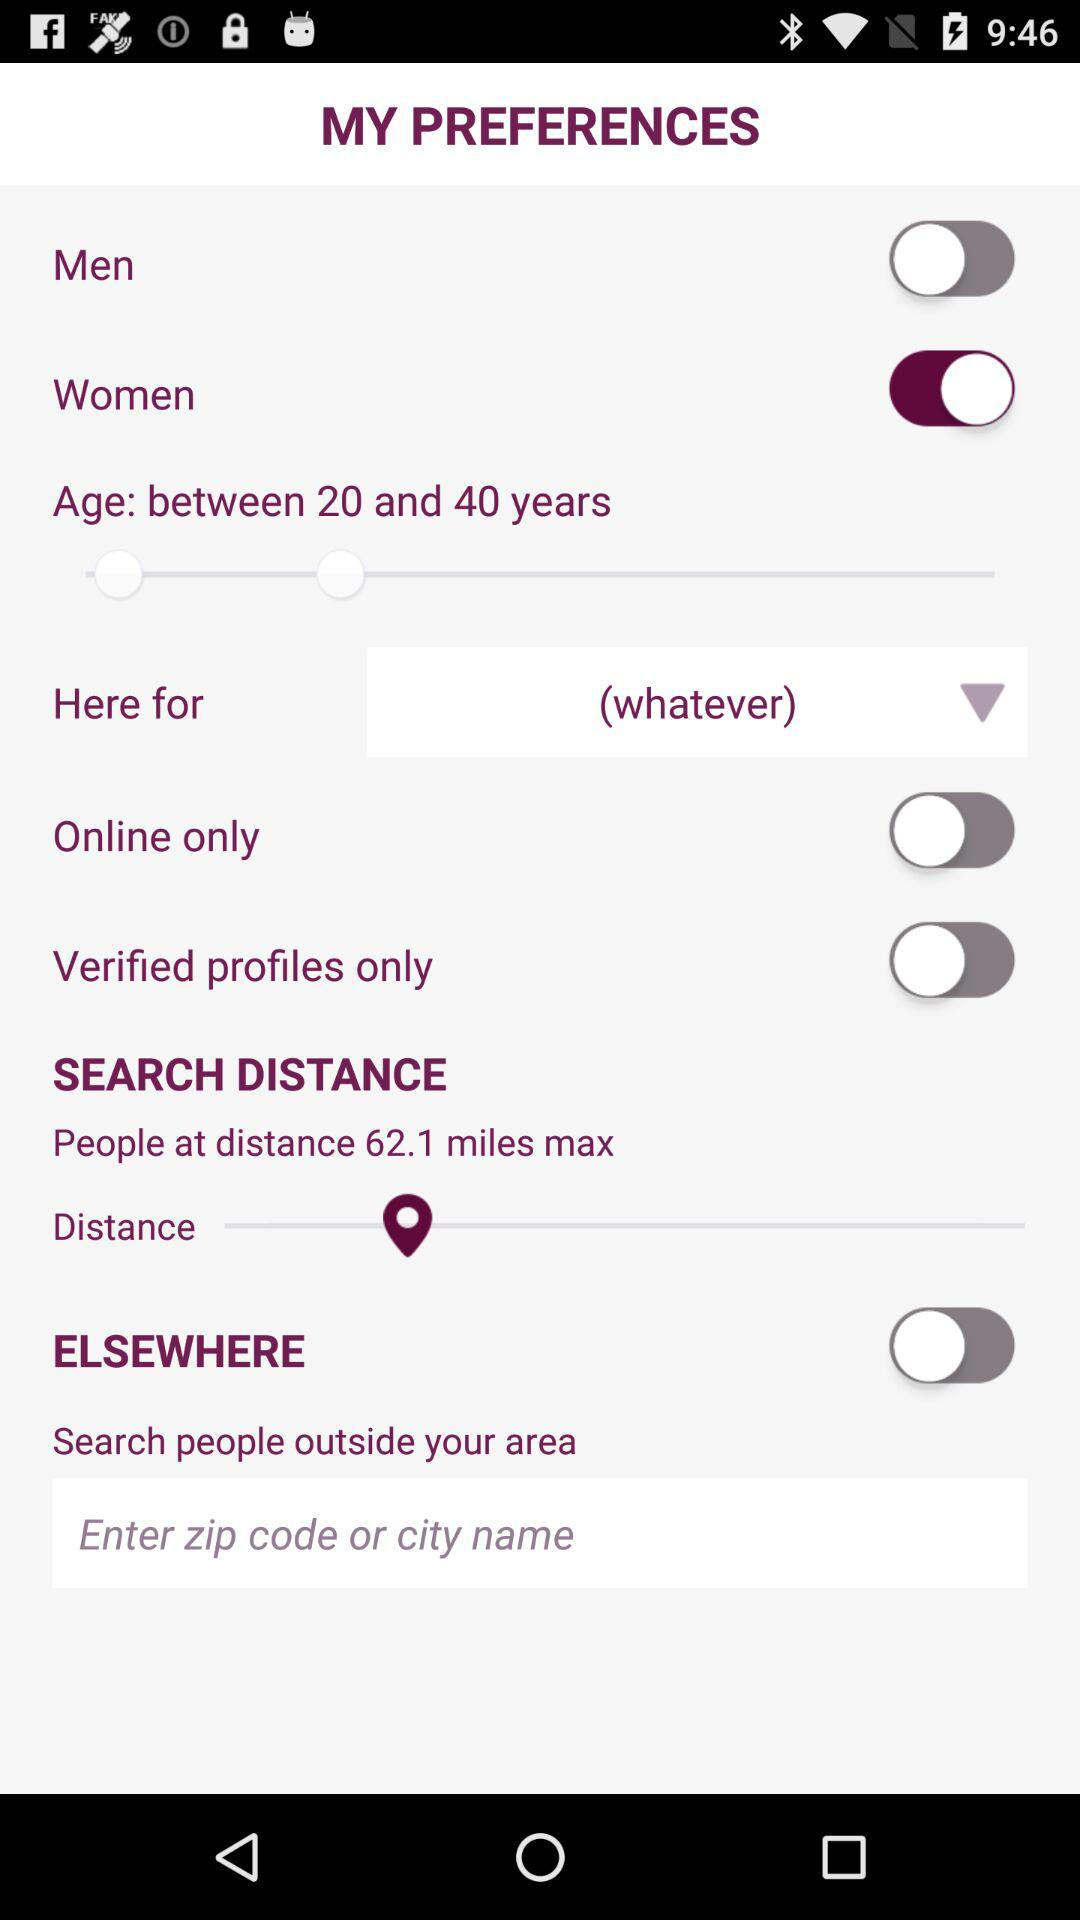What is the selected age range? The selected age range is between 20 years and 40 years. 